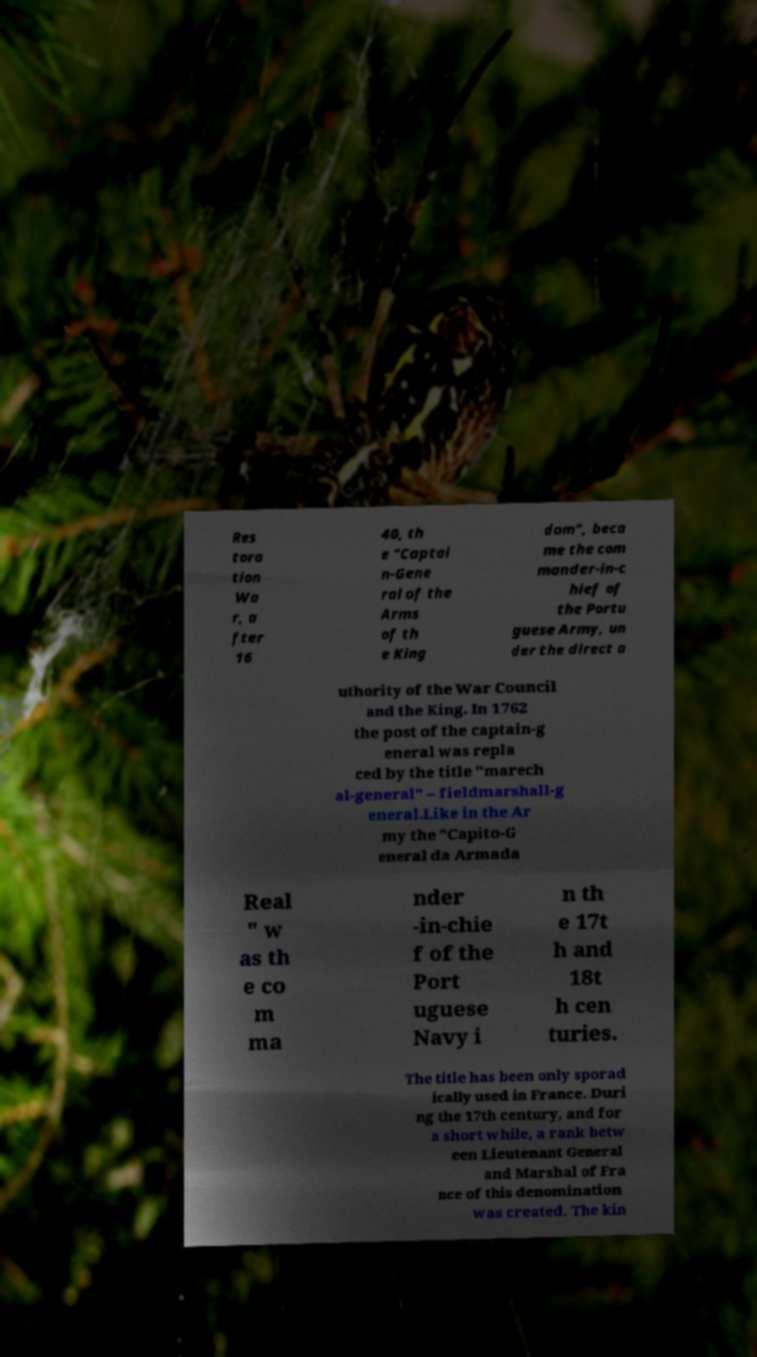What messages or text are displayed in this image? I need them in a readable, typed format. Res tora tion Wa r, a fter 16 40, th e "Captai n-Gene ral of the Arms of th e King dom", beca me the com mander-in-c hief of the Portu guese Army, un der the direct a uthority of the War Council and the King. In 1762 the post of the captain-g eneral was repla ced by the title "marech al-general" – fieldmarshall-g eneral.Like in the Ar my the "Capito-G eneral da Armada Real " w as th e co m ma nder -in-chie f of the Port uguese Navy i n th e 17t h and 18t h cen turies. The title has been only sporad ically used in France. Duri ng the 17th century, and for a short while, a rank betw een Lieutenant General and Marshal of Fra nce of this denomination was created. The kin 